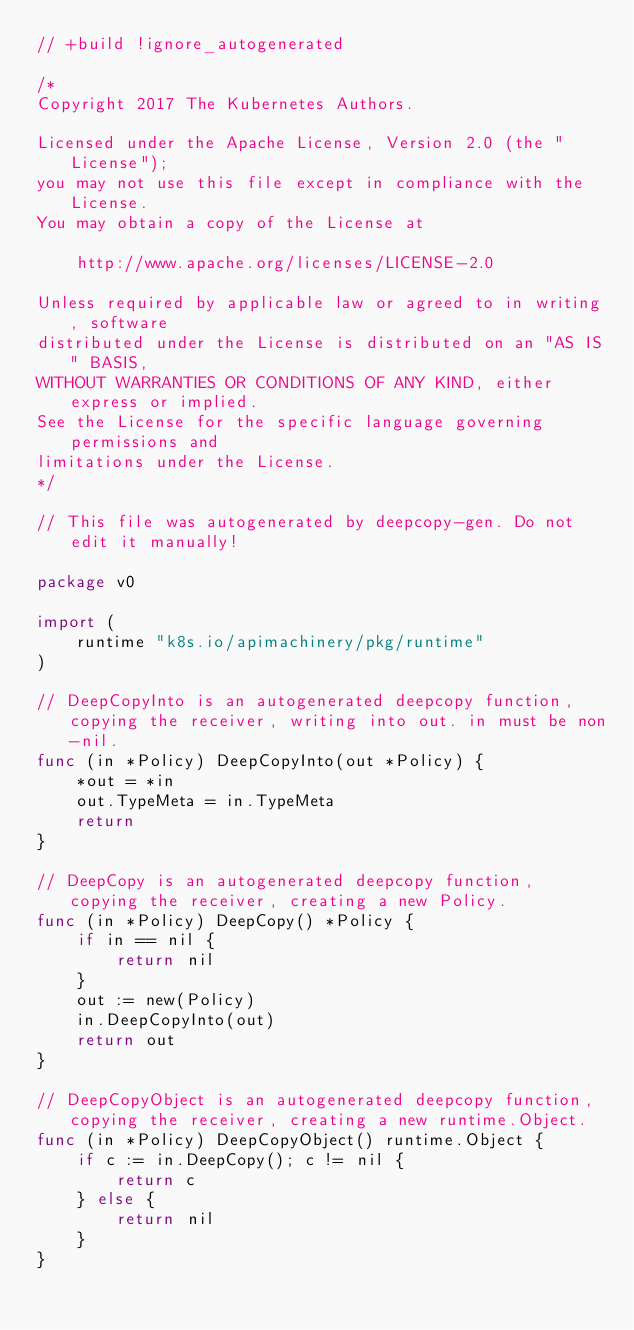Convert code to text. <code><loc_0><loc_0><loc_500><loc_500><_Go_>// +build !ignore_autogenerated

/*
Copyright 2017 The Kubernetes Authors.

Licensed under the Apache License, Version 2.0 (the "License");
you may not use this file except in compliance with the License.
You may obtain a copy of the License at

    http://www.apache.org/licenses/LICENSE-2.0

Unless required by applicable law or agreed to in writing, software
distributed under the License is distributed on an "AS IS" BASIS,
WITHOUT WARRANTIES OR CONDITIONS OF ANY KIND, either express or implied.
See the License for the specific language governing permissions and
limitations under the License.
*/

// This file was autogenerated by deepcopy-gen. Do not edit it manually!

package v0

import (
	runtime "k8s.io/apimachinery/pkg/runtime"
)

// DeepCopyInto is an autogenerated deepcopy function, copying the receiver, writing into out. in must be non-nil.
func (in *Policy) DeepCopyInto(out *Policy) {
	*out = *in
	out.TypeMeta = in.TypeMeta
	return
}

// DeepCopy is an autogenerated deepcopy function, copying the receiver, creating a new Policy.
func (in *Policy) DeepCopy() *Policy {
	if in == nil {
		return nil
	}
	out := new(Policy)
	in.DeepCopyInto(out)
	return out
}

// DeepCopyObject is an autogenerated deepcopy function, copying the receiver, creating a new runtime.Object.
func (in *Policy) DeepCopyObject() runtime.Object {
	if c := in.DeepCopy(); c != nil {
		return c
	} else {
		return nil
	}
}
</code> 